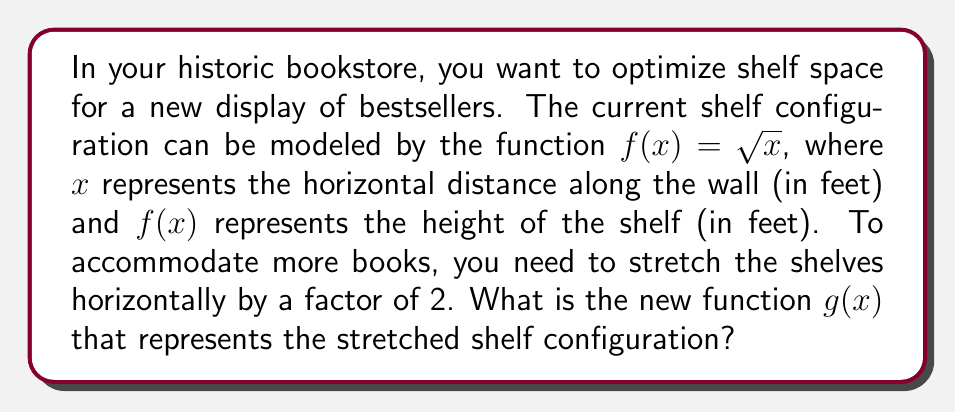Show me your answer to this math problem. To solve this problem, we need to apply a horizontal stretch transformation to the original function $f(x) = \sqrt{x}$.

1) The general form for a horizontal stretch by a factor of $k$ is:
   $g(x) = f(\frac{x}{k})$

2) In this case, we're stretching by a factor of 2, so $k = 2$:
   $g(x) = f(\frac{x}{2})$

3) Now, we substitute the original function $f(x) = \sqrt{x}$ into this form:
   $g(x) = \sqrt{\frac{x}{2}}$

4) To simplify this, we can use the property of square roots:
   $\sqrt{\frac{a}{b}} = \frac{\sqrt{a}}{\sqrt{b}}$

5) Applying this to our function:
   $g(x) = \frac{\sqrt{x}}{\sqrt{2}}$

This new function $g(x)$ represents the stretched shelf configuration. For any given $x$ value (horizontal distance), the height of the shelf will now be $\frac{1}{\sqrt{2}}$ times what it was before, effectively stretching the shelf horizontally by a factor of 2.
Answer: $g(x) = \frac{\sqrt{x}}{\sqrt{2}}$ 